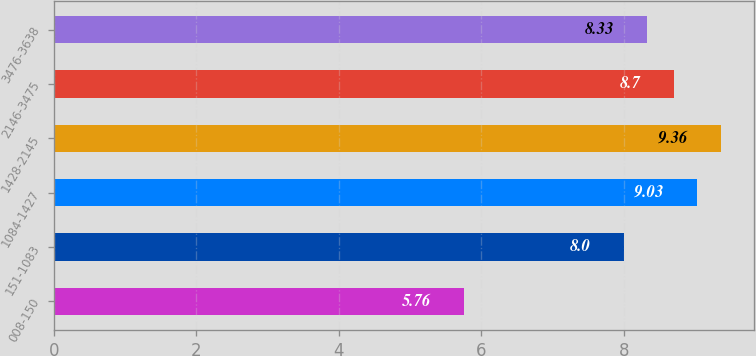Convert chart. <chart><loc_0><loc_0><loc_500><loc_500><bar_chart><fcel>008-150<fcel>151-1083<fcel>1084-1427<fcel>1428-2145<fcel>2146-3475<fcel>3476-3638<nl><fcel>5.76<fcel>8<fcel>9.03<fcel>9.36<fcel>8.7<fcel>8.33<nl></chart> 